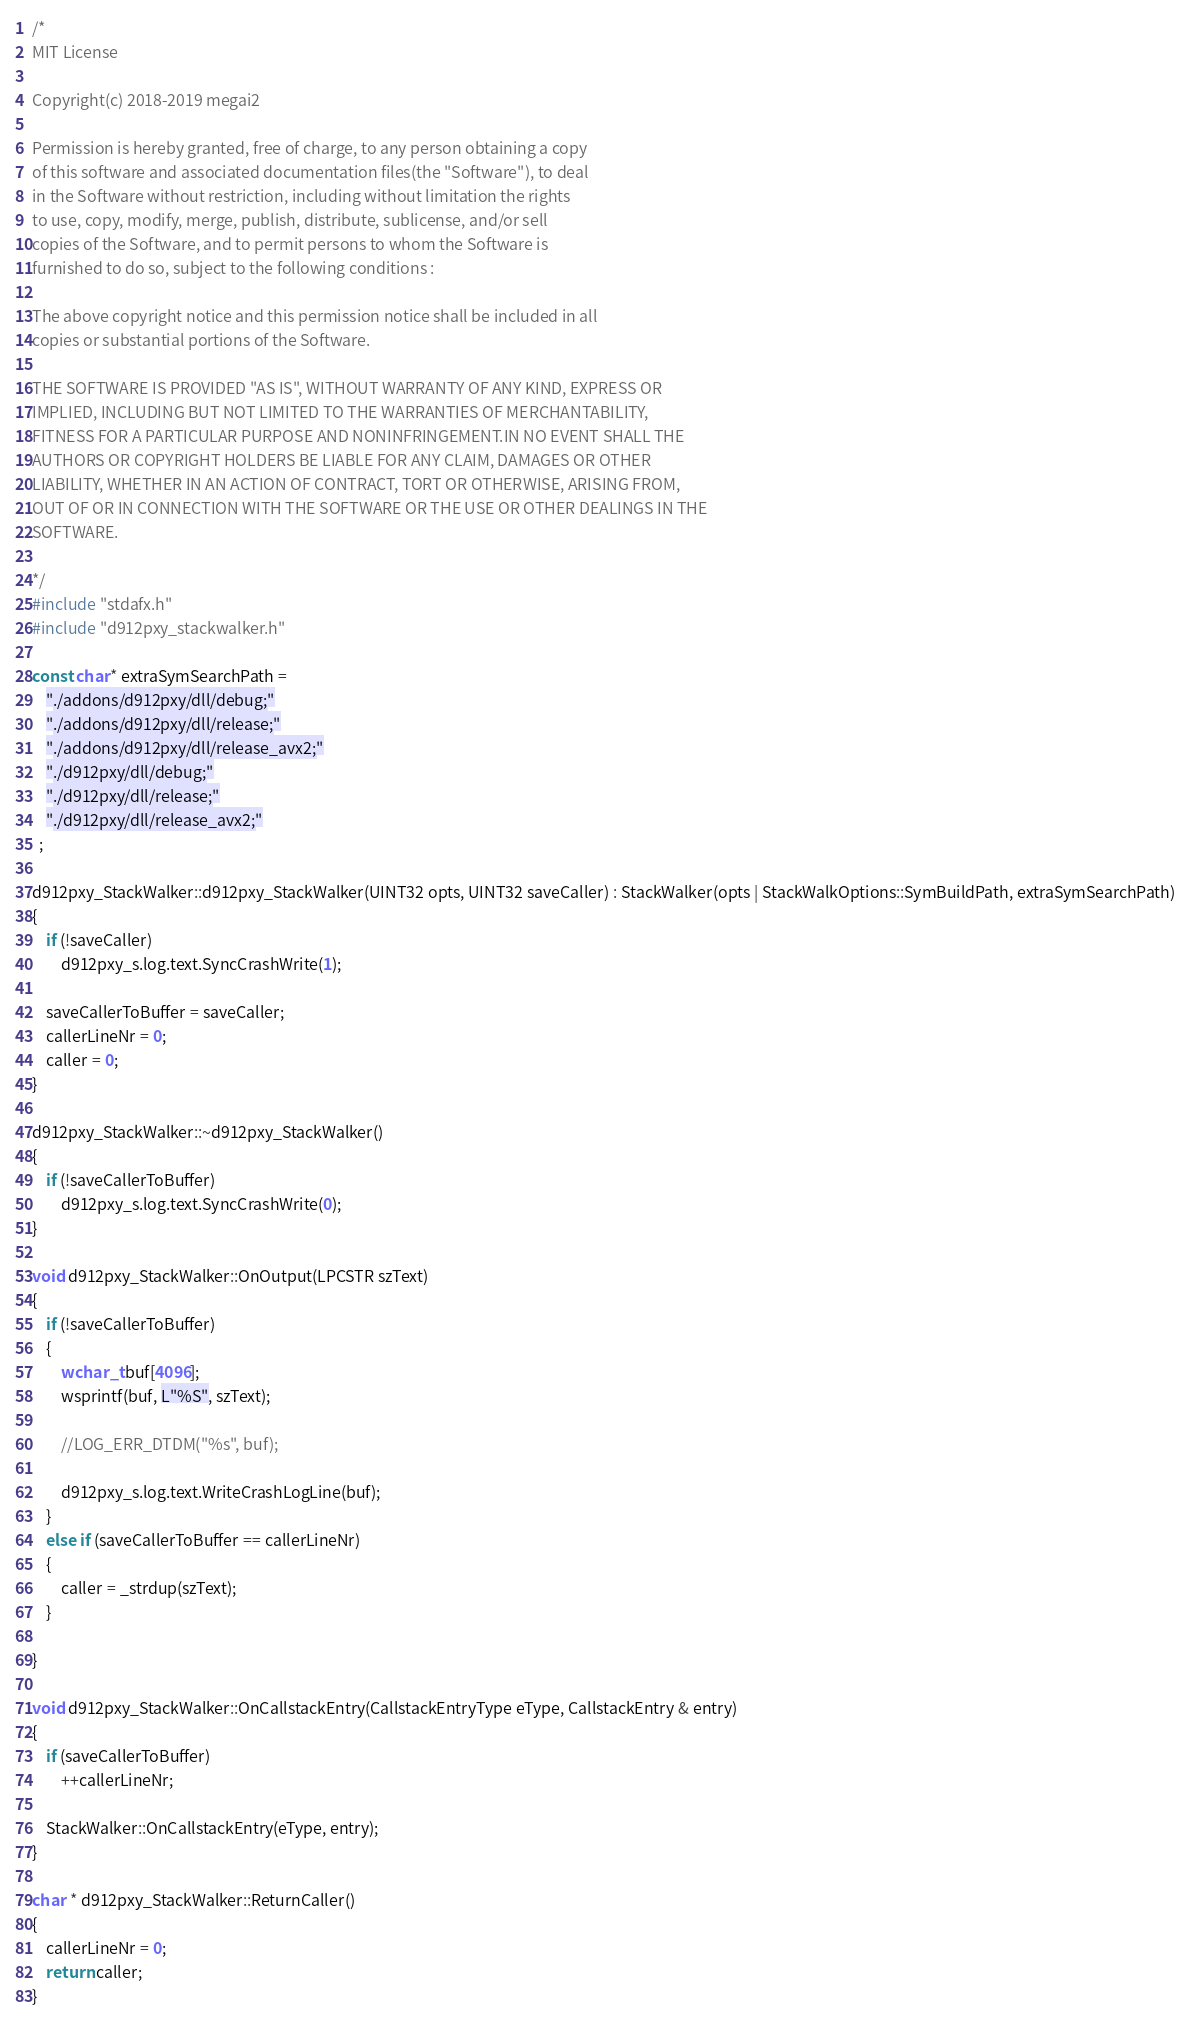Convert code to text. <code><loc_0><loc_0><loc_500><loc_500><_C++_>/*
MIT License

Copyright(c) 2018-2019 megai2

Permission is hereby granted, free of charge, to any person obtaining a copy
of this software and associated documentation files(the "Software"), to deal
in the Software without restriction, including without limitation the rights
to use, copy, modify, merge, publish, distribute, sublicense, and/or sell
copies of the Software, and to permit persons to whom the Software is
furnished to do so, subject to the following conditions :

The above copyright notice and this permission notice shall be included in all
copies or substantial portions of the Software.

THE SOFTWARE IS PROVIDED "AS IS", WITHOUT WARRANTY OF ANY KIND, EXPRESS OR
IMPLIED, INCLUDING BUT NOT LIMITED TO THE WARRANTIES OF MERCHANTABILITY,
FITNESS FOR A PARTICULAR PURPOSE AND NONINFRINGEMENT.IN NO EVENT SHALL THE
AUTHORS OR COPYRIGHT HOLDERS BE LIABLE FOR ANY CLAIM, DAMAGES OR OTHER
LIABILITY, WHETHER IN AN ACTION OF CONTRACT, TORT OR OTHERWISE, ARISING FROM,
OUT OF OR IN CONNECTION WITH THE SOFTWARE OR THE USE OR OTHER DEALINGS IN THE
SOFTWARE.

*/
#include "stdafx.h"
#include "d912pxy_stackwalker.h"

const char* extraSymSearchPath =
	"./addons/d912pxy/dll/debug;"
	"./addons/d912pxy/dll/release;"
	"./addons/d912pxy/dll/release_avx2;"
	"./d912pxy/dll/debug;"
	"./d912pxy/dll/release;"
	"./d912pxy/dll/release_avx2;"
  ;

d912pxy_StackWalker::d912pxy_StackWalker(UINT32 opts, UINT32 saveCaller) : StackWalker(opts | StackWalkOptions::SymBuildPath, extraSymSearchPath)
{
	if (!saveCaller)
		d912pxy_s.log.text.SyncCrashWrite(1);

	saveCallerToBuffer = saveCaller;
	callerLineNr = 0;
	caller = 0;
}

d912pxy_StackWalker::~d912pxy_StackWalker()
{
	if (!saveCallerToBuffer)
		d912pxy_s.log.text.SyncCrashWrite(0);
}

void d912pxy_StackWalker::OnOutput(LPCSTR szText)
{
	if (!saveCallerToBuffer)
	{
		wchar_t buf[4096];
		wsprintf(buf, L"%S", szText);

		//LOG_ERR_DTDM("%s", buf);

		d912pxy_s.log.text.WriteCrashLogLine(buf);
	}
	else if (saveCallerToBuffer == callerLineNr)
	{
		caller = _strdup(szText);
	}

}

void d912pxy_StackWalker::OnCallstackEntry(CallstackEntryType eType, CallstackEntry & entry)
{
	if (saveCallerToBuffer)
		++callerLineNr;
	
	StackWalker::OnCallstackEntry(eType, entry);
}

char * d912pxy_StackWalker::ReturnCaller()
{
	callerLineNr = 0;
	return caller;
}
</code> 